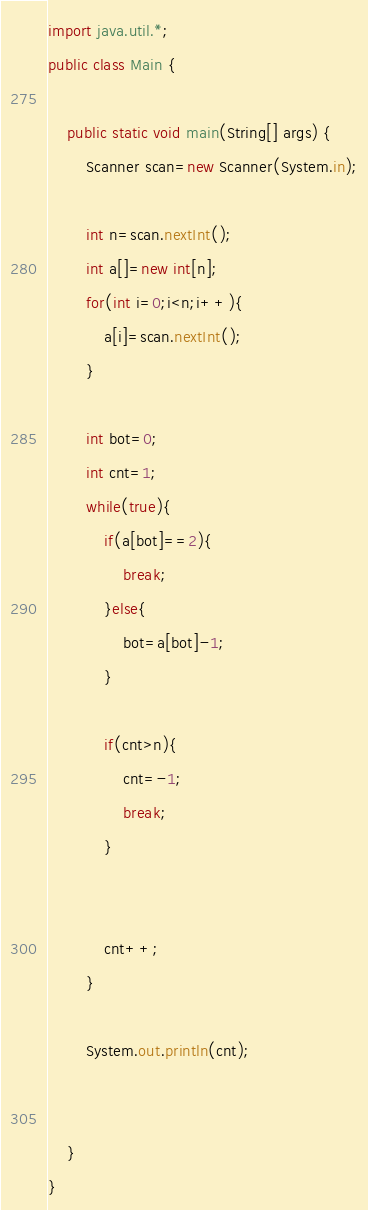<code> <loc_0><loc_0><loc_500><loc_500><_Java_>import java.util.*;
public class Main {

    public static void main(String[] args) {
        Scanner scan=new Scanner(System.in);

        int n=scan.nextInt();
        int a[]=new int[n];
        for(int i=0;i<n;i++){
            a[i]=scan.nextInt();
        }

        int bot=0;
        int cnt=1;
        while(true){
            if(a[bot]==2){
                break;
            }else{
                bot=a[bot]-1;
            }

            if(cnt>n){
                cnt=-1;
                break;
            }


            cnt++;
        }

        System.out.println(cnt);


    }
}</code> 